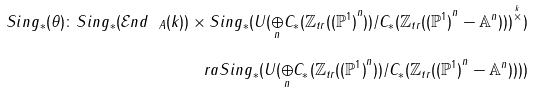Convert formula to latex. <formula><loc_0><loc_0><loc_500><loc_500>S i n g _ { * } ( \theta ) \colon S i n g _ { * } ( { \mathcal { E } } n d _ { \ A } ( k ) ) \times S i n g _ { * } ( U ( { \underset { n } { \oplus } } C _ { * } ( { \mathbb { Z } } _ { t r } ( { ( { \mathbb { P } } ^ { 1 } ) } ^ { n } ) ) / C _ { * } ( { \mathbb { Z } } _ { t r } ( { ( { \mathbb { P } } ^ { 1 } ) } ^ { n } - { \mathbb { A } } ^ { n } ) ) ) ^ { \overset { k } { \times } } ) \\ \ r a S i n g _ { * } ( U ( { \underset { n } { \oplus } } C _ { * } ( { \mathbb { Z } } _ { t r } ( { ( { \mathbb { P } } ^ { 1 } ) } ^ { n } ) ) / C _ { * } ( { \mathbb { Z } } _ { t r } ( { ( { \mathbb { P } } ^ { 1 } ) } ^ { n } - { \mathbb { A } } ^ { n } ) ) ) )</formula> 